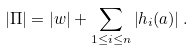<formula> <loc_0><loc_0><loc_500><loc_500>\left | \Pi \right | = \left | w \right | + \sum _ { 1 \leq i \leq n } \left | h _ { i } ( a ) \right | .</formula> 